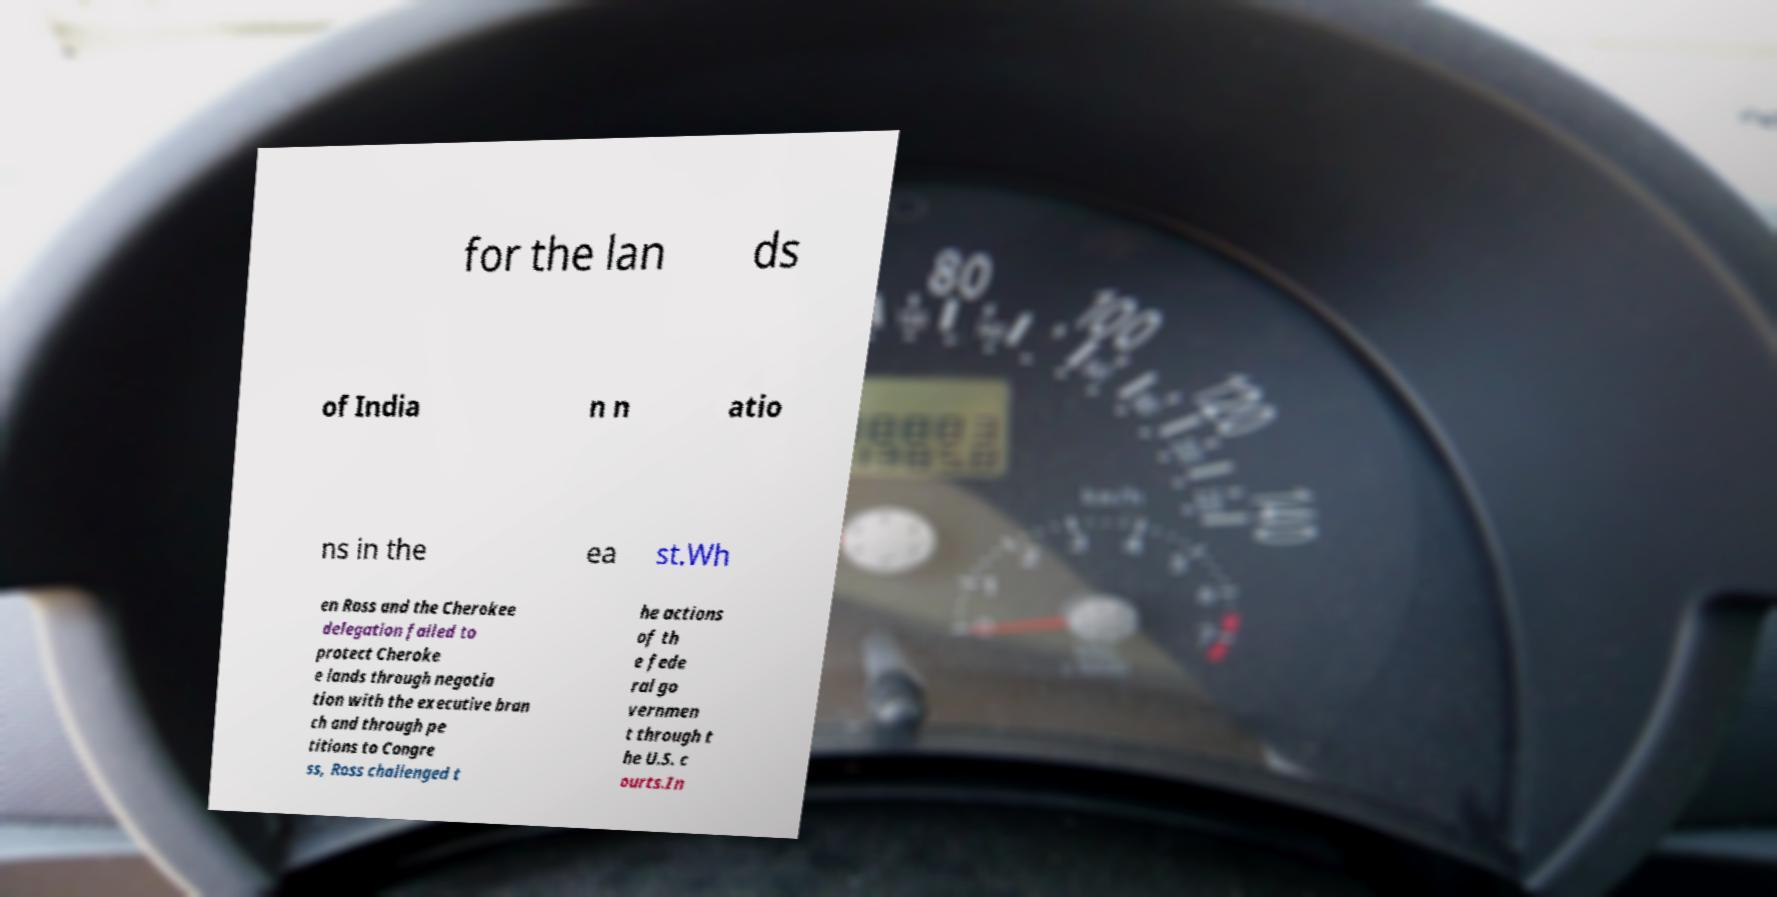Can you accurately transcribe the text from the provided image for me? for the lan ds of India n n atio ns in the ea st.Wh en Ross and the Cherokee delegation failed to protect Cheroke e lands through negotia tion with the executive bran ch and through pe titions to Congre ss, Ross challenged t he actions of th e fede ral go vernmen t through t he U.S. c ourts.In 